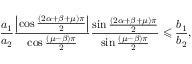Convert formula to latex. <formula><loc_0><loc_0><loc_500><loc_500>\frac { a _ { 1 } } { a _ { 2 } } \frac { \left | \cos \frac { \left ( 2 \alpha + \beta + \mu \right ) \pi } { 2 } \right | } { \cos \frac { \left ( \mu - \beta \right ) \pi } { 2 } } \frac { \sin \frac { \left ( 2 \alpha + \beta + \mu \right ) \pi } { 2 } } { \sin \frac { \left ( \mu - \beta \right ) \pi } { 2 } } \leqslant \frac { b _ { 1 } } { b _ { 2 } } ,</formula> 